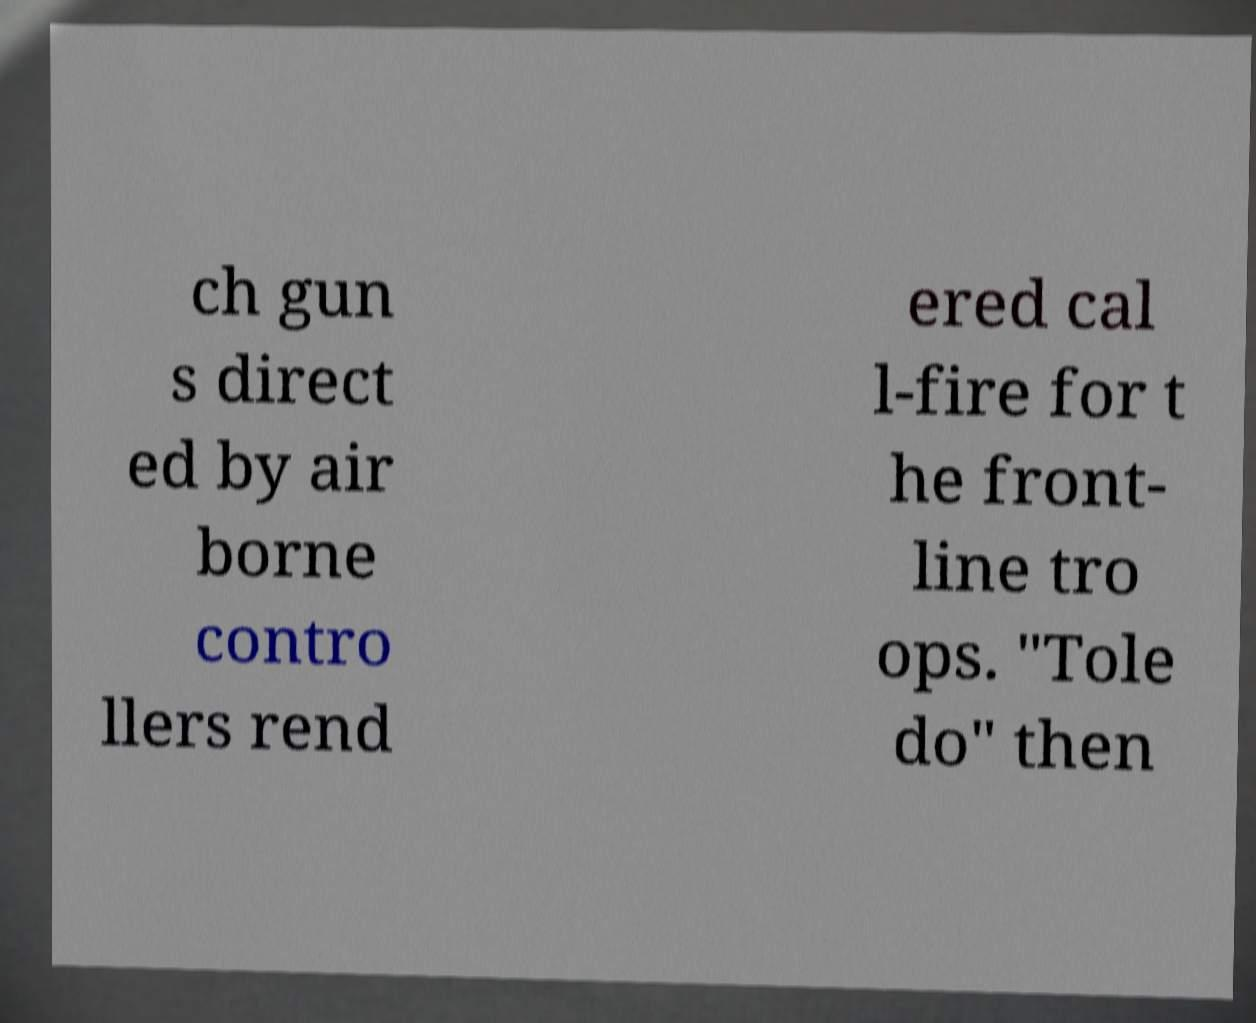What messages or text are displayed in this image? I need them in a readable, typed format. ch gun s direct ed by air borne contro llers rend ered cal l-fire for t he front- line tro ops. "Tole do" then 